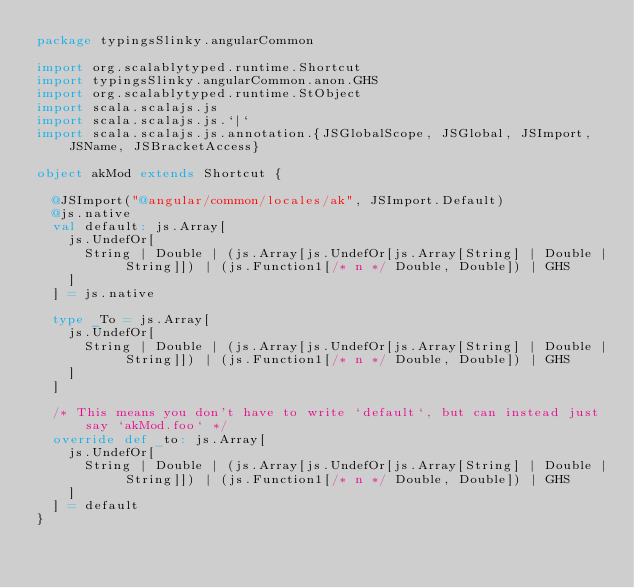<code> <loc_0><loc_0><loc_500><loc_500><_Scala_>package typingsSlinky.angularCommon

import org.scalablytyped.runtime.Shortcut
import typingsSlinky.angularCommon.anon.GHS
import org.scalablytyped.runtime.StObject
import scala.scalajs.js
import scala.scalajs.js.`|`
import scala.scalajs.js.annotation.{JSGlobalScope, JSGlobal, JSImport, JSName, JSBracketAccess}

object akMod extends Shortcut {
  
  @JSImport("@angular/common/locales/ak", JSImport.Default)
  @js.native
  val default: js.Array[
    js.UndefOr[
      String | Double | (js.Array[js.UndefOr[js.Array[String] | Double | String]]) | (js.Function1[/* n */ Double, Double]) | GHS
    ]
  ] = js.native
  
  type _To = js.Array[
    js.UndefOr[
      String | Double | (js.Array[js.UndefOr[js.Array[String] | Double | String]]) | (js.Function1[/* n */ Double, Double]) | GHS
    ]
  ]
  
  /* This means you don't have to write `default`, but can instead just say `akMod.foo` */
  override def _to: js.Array[
    js.UndefOr[
      String | Double | (js.Array[js.UndefOr[js.Array[String] | Double | String]]) | (js.Function1[/* n */ Double, Double]) | GHS
    ]
  ] = default
}
</code> 